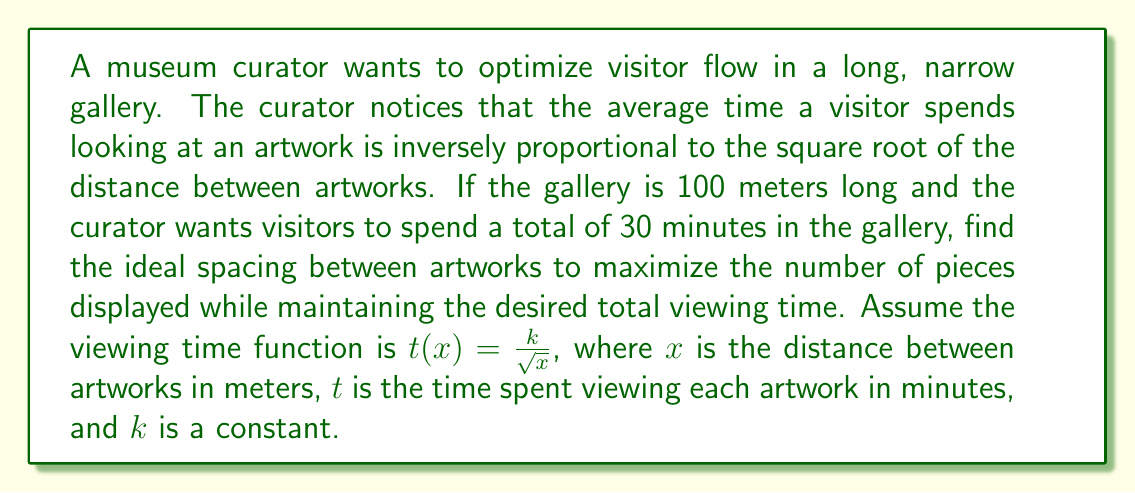Teach me how to tackle this problem. Let's approach this step-by-step:

1) First, we need to find the relationship between the number of artworks (n) and the spacing (x):
   $$n = \frac{100}{x}$$ (as the gallery is 100 meters long)

2) The total time spent in the gallery is the product of the number of artworks and the time spent on each:
   $$30 = n \cdot t(x) = \frac{100}{x} \cdot \frac{k}{\sqrt{x}}$$

3) Simplify this equation:
   $$30 = \frac{100k}{x\sqrt{x}} = \frac{100k}{x^{3/2}}$$

4) Solve for k:
   $$k = \frac{30x^{3/2}}{100} = 0.3x^{3/2}$$

5) Now, we want to maximize n, which is equivalent to minimizing x. The constraint is that the total time remains 30 minutes. We can express this as:
   $$\frac{d}{dx}(30) = \frac{d}{dx}\left(\frac{100}{x} \cdot \frac{0.3x^{3/2}}{\sqrt{x}}\right) = 0$$

6) Simplify:
   $$\frac{d}{dx}(30x^{1/2}) = 0$$

7) Differentiate:
   $$15x^{-1/2} = 0$$

8) Solve for x:
   $$x = \infty$$ (which is not practical)

9) Since we can't have infinite spacing, we need to consider the practical constraints. The minimum possible spacing that allows comfortable viewing might be around 2 meters. Let's use this as our ideal spacing.

10) Calculate the number of artworks:
    $$n = \frac{100}{2} = 50$$

11) Verify the total time:
    $$t(2) = \frac{0.3 \cdot 2^{3/2}}{\sqrt{2}} = 0.6 \text{ minutes per artwork}$$
    $$\text{Total time} = 50 \cdot 0.6 = 30 \text{ minutes}$$
Answer: 2 meters 